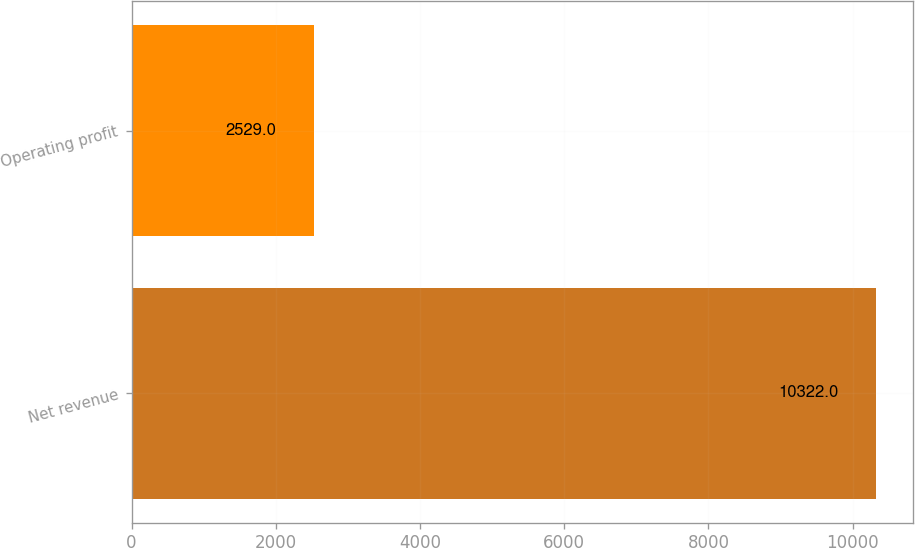<chart> <loc_0><loc_0><loc_500><loc_500><bar_chart><fcel>Net revenue<fcel>Operating profit<nl><fcel>10322<fcel>2529<nl></chart> 